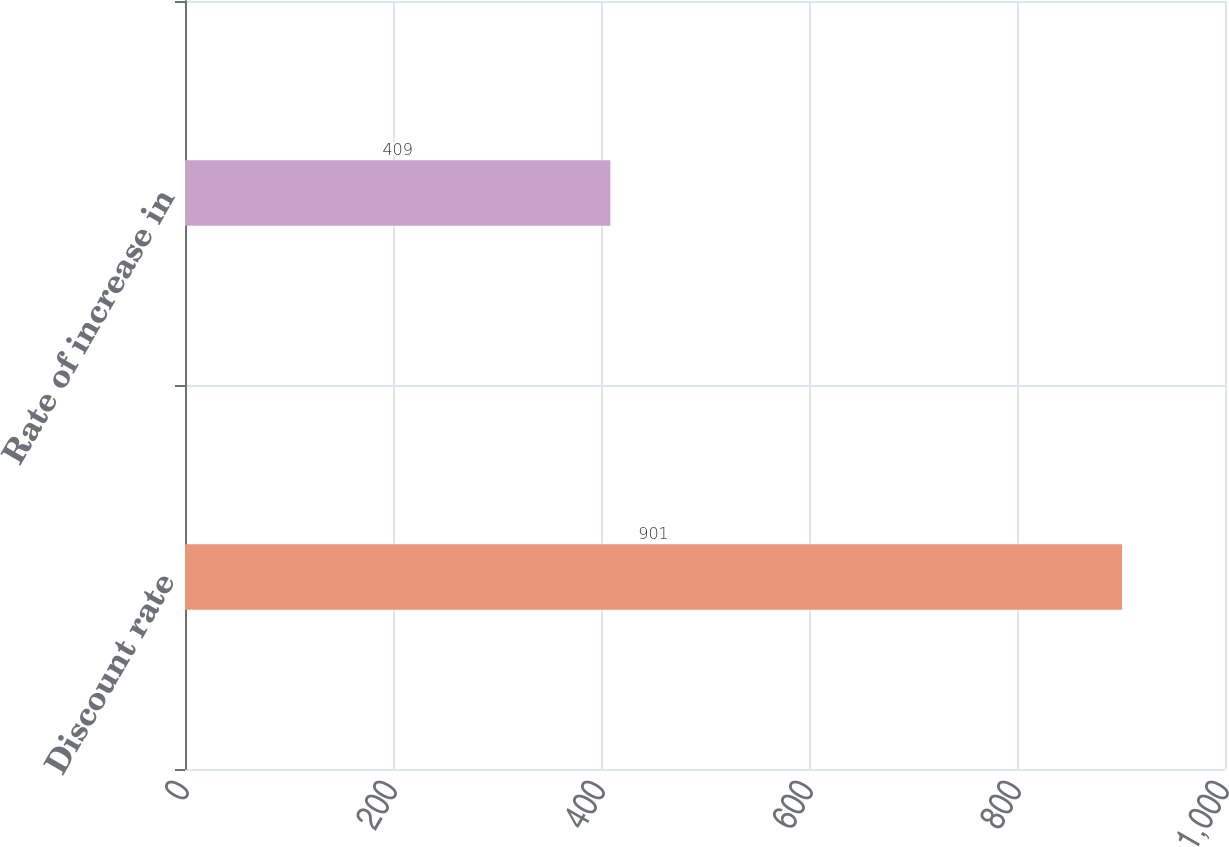Convert chart. <chart><loc_0><loc_0><loc_500><loc_500><bar_chart><fcel>Discount rate<fcel>Rate of increase in<nl><fcel>901<fcel>409<nl></chart> 